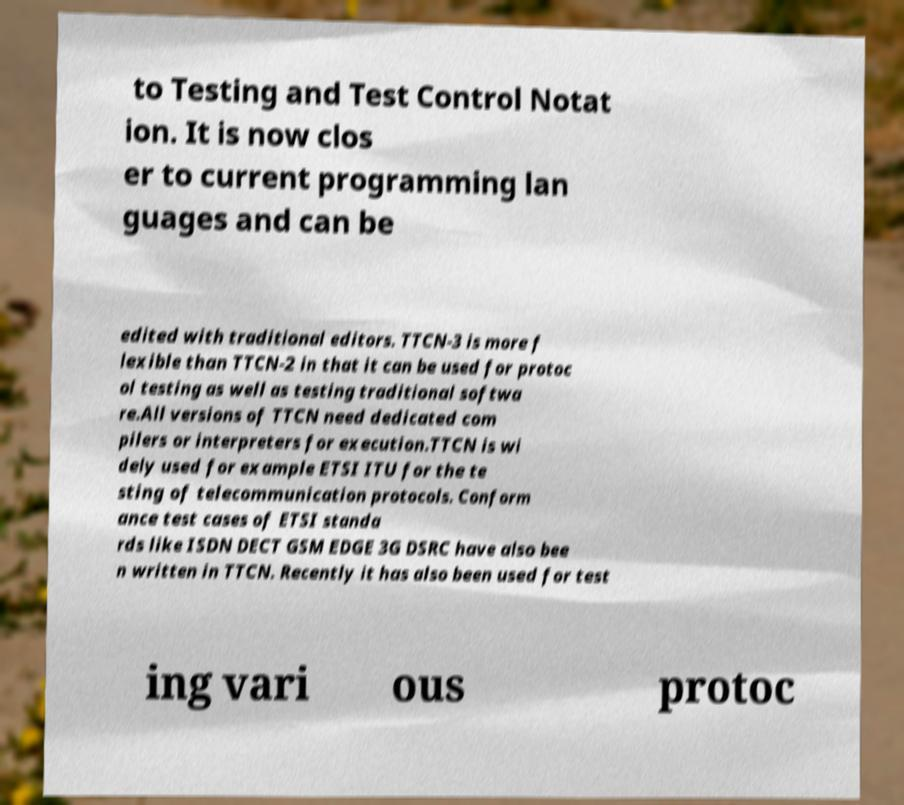Please identify and transcribe the text found in this image. to Testing and Test Control Notat ion. It is now clos er to current programming lan guages and can be edited with traditional editors. TTCN-3 is more f lexible than TTCN-2 in that it can be used for protoc ol testing as well as testing traditional softwa re.All versions of TTCN need dedicated com pilers or interpreters for execution.TTCN is wi dely used for example ETSI ITU for the te sting of telecommunication protocols. Conform ance test cases of ETSI standa rds like ISDN DECT GSM EDGE 3G DSRC have also bee n written in TTCN. Recently it has also been used for test ing vari ous protoc 